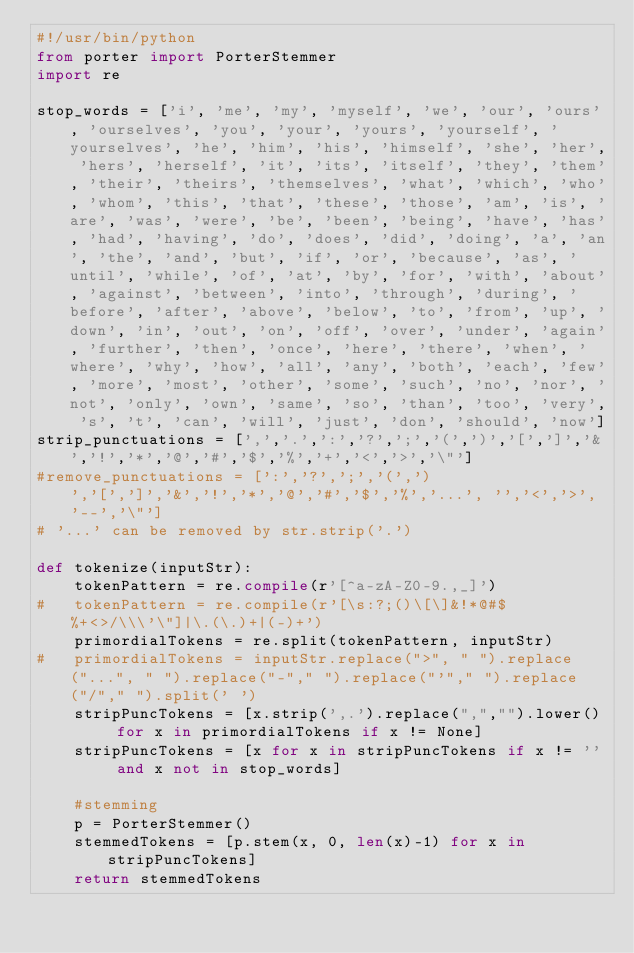<code> <loc_0><loc_0><loc_500><loc_500><_Python_>#!/usr/bin/python
from porter import PorterStemmer
import re

stop_words = ['i', 'me', 'my', 'myself', 'we', 'our', 'ours', 'ourselves', 'you', 'your', 'yours', 'yourself', 'yourselves', 'he', 'him', 'his', 'himself', 'she', 'her', 'hers', 'herself', 'it', 'its', 'itself', 'they', 'them', 'their', 'theirs', 'themselves', 'what', 'which', 'who', 'whom', 'this', 'that', 'these', 'those', 'am', 'is', 'are', 'was', 'were', 'be', 'been', 'being', 'have', 'has', 'had', 'having', 'do', 'does', 'did', 'doing', 'a', 'an', 'the', 'and', 'but', 'if', 'or', 'because', 'as', 'until', 'while', 'of', 'at', 'by', 'for', 'with', 'about', 'against', 'between', 'into', 'through', 'during', 'before', 'after', 'above', 'below', 'to', 'from', 'up', 'down', 'in', 'out', 'on', 'off', 'over', 'under', 'again', 'further', 'then', 'once', 'here', 'there', 'when', 'where', 'why', 'how', 'all', 'any', 'both', 'each', 'few', 'more', 'most', 'other', 'some', 'such', 'no', 'nor', 'not', 'only', 'own', 'same', 'so', 'than', 'too', 'very', 's', 't', 'can', 'will', 'just', 'don', 'should', 'now']
strip_punctuations = [',','.',':','?',';','(',')','[',']','&','!','*','@','#','$','%','+','<','>','\"']
#remove_punctuations = [':','?',';','(',')','[',']','&','!','*','@','#','$','%','...', '','<','>', '--','\"']
# '...' can be removed by str.strip('.')

def tokenize(inputStr):
	tokenPattern = re.compile(r'[^a-zA-Z0-9.,_]')	
#	tokenPattern = re.compile(r'[\s:?;()\[\]&!*@#$%+<>/\\\'\"]|\.(\.)+|(-)+')
	primordialTokens = re.split(tokenPattern, inputStr)
#	primordialTokens = inputStr.replace(">", " ").replace("...", " ").replace("-"," ").replace("'"," ").replace("/"," ").split(' ')
	stripPuncTokens = [x.strip(',.').replace(",","").lower() for x in primordialTokens if x != None]
	stripPuncTokens = [x for x in stripPuncTokens if x != '' and x not in stop_words]

	#stemming
	p = PorterStemmer()
	stemmedTokens = [p.stem(x, 0, len(x)-1) for x in stripPuncTokens]
	return stemmedTokens
</code> 